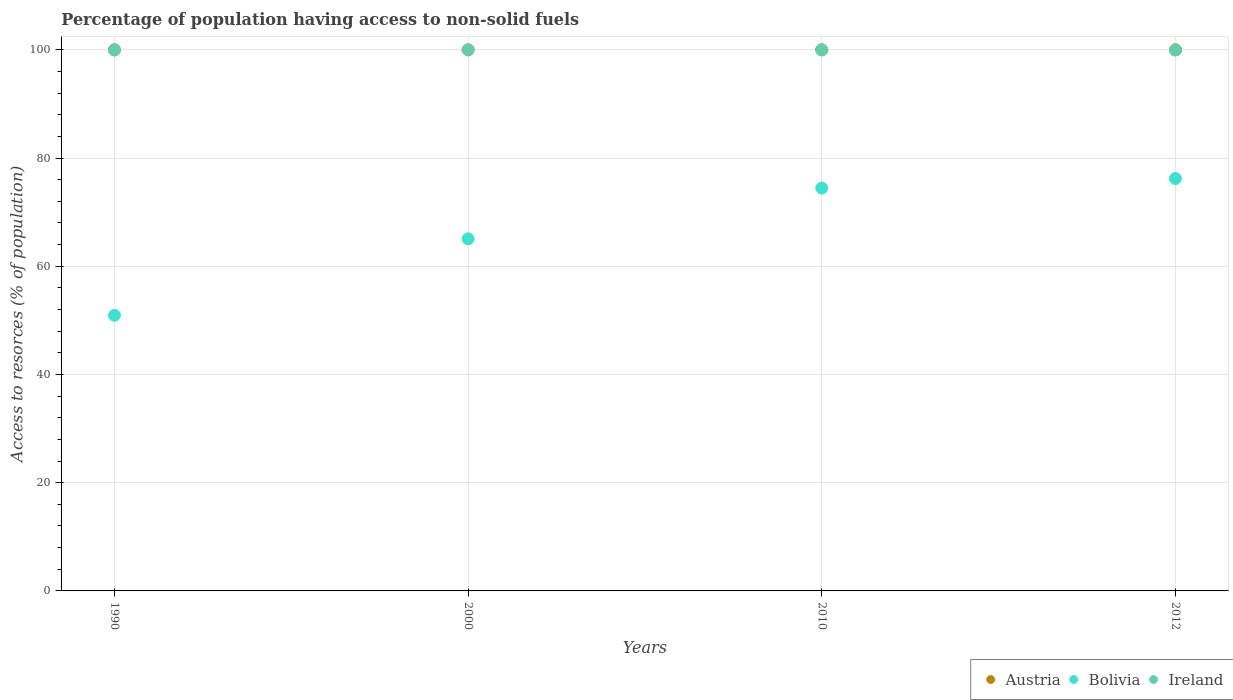How many different coloured dotlines are there?
Give a very brief answer. 3. Is the number of dotlines equal to the number of legend labels?
Offer a terse response. Yes. What is the percentage of population having access to non-solid fuels in Austria in 2000?
Provide a short and direct response. 100. Across all years, what is the maximum percentage of population having access to non-solid fuels in Bolivia?
Offer a very short reply. 76.21. Across all years, what is the minimum percentage of population having access to non-solid fuels in Austria?
Give a very brief answer. 100. In which year was the percentage of population having access to non-solid fuels in Ireland minimum?
Give a very brief answer. 1990. What is the total percentage of population having access to non-solid fuels in Austria in the graph?
Offer a terse response. 400. What is the difference between the percentage of population having access to non-solid fuels in Bolivia in 1990 and that in 2012?
Provide a short and direct response. -25.28. What is the difference between the percentage of population having access to non-solid fuels in Ireland in 2000 and the percentage of population having access to non-solid fuels in Austria in 2012?
Offer a very short reply. 0. In the year 1990, what is the difference between the percentage of population having access to non-solid fuels in Austria and percentage of population having access to non-solid fuels in Bolivia?
Make the answer very short. 49.06. Is the percentage of population having access to non-solid fuels in Ireland in 2000 less than that in 2010?
Keep it short and to the point. No. What is the difference between the highest and the lowest percentage of population having access to non-solid fuels in Austria?
Offer a terse response. 0. In how many years, is the percentage of population having access to non-solid fuels in Bolivia greater than the average percentage of population having access to non-solid fuels in Bolivia taken over all years?
Your answer should be compact. 2. Is it the case that in every year, the sum of the percentage of population having access to non-solid fuels in Bolivia and percentage of population having access to non-solid fuels in Ireland  is greater than the percentage of population having access to non-solid fuels in Austria?
Offer a terse response. Yes. Is the percentage of population having access to non-solid fuels in Austria strictly greater than the percentage of population having access to non-solid fuels in Bolivia over the years?
Your answer should be very brief. Yes. How many dotlines are there?
Provide a succinct answer. 3. How many years are there in the graph?
Provide a succinct answer. 4. What is the difference between two consecutive major ticks on the Y-axis?
Ensure brevity in your answer.  20. Are the values on the major ticks of Y-axis written in scientific E-notation?
Keep it short and to the point. No. How many legend labels are there?
Make the answer very short. 3. What is the title of the graph?
Offer a very short reply. Percentage of population having access to non-solid fuels. Does "Ireland" appear as one of the legend labels in the graph?
Keep it short and to the point. Yes. What is the label or title of the X-axis?
Keep it short and to the point. Years. What is the label or title of the Y-axis?
Your answer should be very brief. Access to resorces (% of population). What is the Access to resorces (% of population) of Austria in 1990?
Provide a succinct answer. 100. What is the Access to resorces (% of population) in Bolivia in 1990?
Give a very brief answer. 50.94. What is the Access to resorces (% of population) of Austria in 2000?
Your answer should be compact. 100. What is the Access to resorces (% of population) in Bolivia in 2000?
Your answer should be compact. 65.07. What is the Access to resorces (% of population) of Bolivia in 2010?
Offer a very short reply. 74.45. What is the Access to resorces (% of population) of Austria in 2012?
Give a very brief answer. 100. What is the Access to resorces (% of population) in Bolivia in 2012?
Give a very brief answer. 76.21. What is the Access to resorces (% of population) of Ireland in 2012?
Offer a very short reply. 100. Across all years, what is the maximum Access to resorces (% of population) in Bolivia?
Offer a terse response. 76.21. Across all years, what is the maximum Access to resorces (% of population) of Ireland?
Your answer should be compact. 100. Across all years, what is the minimum Access to resorces (% of population) of Austria?
Ensure brevity in your answer.  100. Across all years, what is the minimum Access to resorces (% of population) in Bolivia?
Make the answer very short. 50.94. What is the total Access to resorces (% of population) of Bolivia in the graph?
Provide a succinct answer. 266.67. What is the difference between the Access to resorces (% of population) of Bolivia in 1990 and that in 2000?
Your response must be concise. -14.13. What is the difference between the Access to resorces (% of population) of Austria in 1990 and that in 2010?
Your answer should be compact. 0. What is the difference between the Access to resorces (% of population) of Bolivia in 1990 and that in 2010?
Your answer should be compact. -23.51. What is the difference between the Access to resorces (% of population) of Ireland in 1990 and that in 2010?
Your response must be concise. 0. What is the difference between the Access to resorces (% of population) of Bolivia in 1990 and that in 2012?
Provide a succinct answer. -25.28. What is the difference between the Access to resorces (% of population) of Bolivia in 2000 and that in 2010?
Your answer should be very brief. -9.38. What is the difference between the Access to resorces (% of population) of Ireland in 2000 and that in 2010?
Give a very brief answer. 0. What is the difference between the Access to resorces (% of population) in Austria in 2000 and that in 2012?
Provide a succinct answer. 0. What is the difference between the Access to resorces (% of population) in Bolivia in 2000 and that in 2012?
Your answer should be very brief. -11.14. What is the difference between the Access to resorces (% of population) in Ireland in 2000 and that in 2012?
Offer a very short reply. 0. What is the difference between the Access to resorces (% of population) of Bolivia in 2010 and that in 2012?
Provide a short and direct response. -1.76. What is the difference between the Access to resorces (% of population) of Austria in 1990 and the Access to resorces (% of population) of Bolivia in 2000?
Keep it short and to the point. 34.93. What is the difference between the Access to resorces (% of population) in Bolivia in 1990 and the Access to resorces (% of population) in Ireland in 2000?
Make the answer very short. -49.06. What is the difference between the Access to resorces (% of population) of Austria in 1990 and the Access to resorces (% of population) of Bolivia in 2010?
Your response must be concise. 25.55. What is the difference between the Access to resorces (% of population) of Austria in 1990 and the Access to resorces (% of population) of Ireland in 2010?
Provide a succinct answer. 0. What is the difference between the Access to resorces (% of population) in Bolivia in 1990 and the Access to resorces (% of population) in Ireland in 2010?
Give a very brief answer. -49.06. What is the difference between the Access to resorces (% of population) of Austria in 1990 and the Access to resorces (% of population) of Bolivia in 2012?
Provide a succinct answer. 23.79. What is the difference between the Access to resorces (% of population) of Bolivia in 1990 and the Access to resorces (% of population) of Ireland in 2012?
Offer a very short reply. -49.06. What is the difference between the Access to resorces (% of population) in Austria in 2000 and the Access to resorces (% of population) in Bolivia in 2010?
Ensure brevity in your answer.  25.55. What is the difference between the Access to resorces (% of population) of Bolivia in 2000 and the Access to resorces (% of population) of Ireland in 2010?
Provide a succinct answer. -34.93. What is the difference between the Access to resorces (% of population) in Austria in 2000 and the Access to resorces (% of population) in Bolivia in 2012?
Make the answer very short. 23.79. What is the difference between the Access to resorces (% of population) of Bolivia in 2000 and the Access to resorces (% of population) of Ireland in 2012?
Provide a succinct answer. -34.93. What is the difference between the Access to resorces (% of population) of Austria in 2010 and the Access to resorces (% of population) of Bolivia in 2012?
Your answer should be very brief. 23.79. What is the difference between the Access to resorces (% of population) in Bolivia in 2010 and the Access to resorces (% of population) in Ireland in 2012?
Keep it short and to the point. -25.55. What is the average Access to resorces (% of population) of Austria per year?
Give a very brief answer. 100. What is the average Access to resorces (% of population) of Bolivia per year?
Make the answer very short. 66.67. In the year 1990, what is the difference between the Access to resorces (% of population) in Austria and Access to resorces (% of population) in Bolivia?
Give a very brief answer. 49.06. In the year 1990, what is the difference between the Access to resorces (% of population) of Bolivia and Access to resorces (% of population) of Ireland?
Provide a succinct answer. -49.06. In the year 2000, what is the difference between the Access to resorces (% of population) of Austria and Access to resorces (% of population) of Bolivia?
Keep it short and to the point. 34.93. In the year 2000, what is the difference between the Access to resorces (% of population) in Austria and Access to resorces (% of population) in Ireland?
Offer a very short reply. 0. In the year 2000, what is the difference between the Access to resorces (% of population) of Bolivia and Access to resorces (% of population) of Ireland?
Offer a very short reply. -34.93. In the year 2010, what is the difference between the Access to resorces (% of population) of Austria and Access to resorces (% of population) of Bolivia?
Ensure brevity in your answer.  25.55. In the year 2010, what is the difference between the Access to resorces (% of population) in Bolivia and Access to resorces (% of population) in Ireland?
Ensure brevity in your answer.  -25.55. In the year 2012, what is the difference between the Access to resorces (% of population) in Austria and Access to resorces (% of population) in Bolivia?
Provide a succinct answer. 23.79. In the year 2012, what is the difference between the Access to resorces (% of population) in Bolivia and Access to resorces (% of population) in Ireland?
Ensure brevity in your answer.  -23.79. What is the ratio of the Access to resorces (% of population) of Bolivia in 1990 to that in 2000?
Provide a succinct answer. 0.78. What is the ratio of the Access to resorces (% of population) of Ireland in 1990 to that in 2000?
Ensure brevity in your answer.  1. What is the ratio of the Access to resorces (% of population) of Bolivia in 1990 to that in 2010?
Offer a very short reply. 0.68. What is the ratio of the Access to resorces (% of population) of Bolivia in 1990 to that in 2012?
Your response must be concise. 0.67. What is the ratio of the Access to resorces (% of population) of Austria in 2000 to that in 2010?
Keep it short and to the point. 1. What is the ratio of the Access to resorces (% of population) of Bolivia in 2000 to that in 2010?
Ensure brevity in your answer.  0.87. What is the ratio of the Access to resorces (% of population) in Ireland in 2000 to that in 2010?
Provide a succinct answer. 1. What is the ratio of the Access to resorces (% of population) in Austria in 2000 to that in 2012?
Offer a terse response. 1. What is the ratio of the Access to resorces (% of population) of Bolivia in 2000 to that in 2012?
Your answer should be compact. 0.85. What is the ratio of the Access to resorces (% of population) in Bolivia in 2010 to that in 2012?
Offer a terse response. 0.98. What is the ratio of the Access to resorces (% of population) of Ireland in 2010 to that in 2012?
Your response must be concise. 1. What is the difference between the highest and the second highest Access to resorces (% of population) in Austria?
Give a very brief answer. 0. What is the difference between the highest and the second highest Access to resorces (% of population) of Bolivia?
Offer a terse response. 1.76. What is the difference between the highest and the lowest Access to resorces (% of population) of Bolivia?
Your response must be concise. 25.28. What is the difference between the highest and the lowest Access to resorces (% of population) in Ireland?
Your response must be concise. 0. 